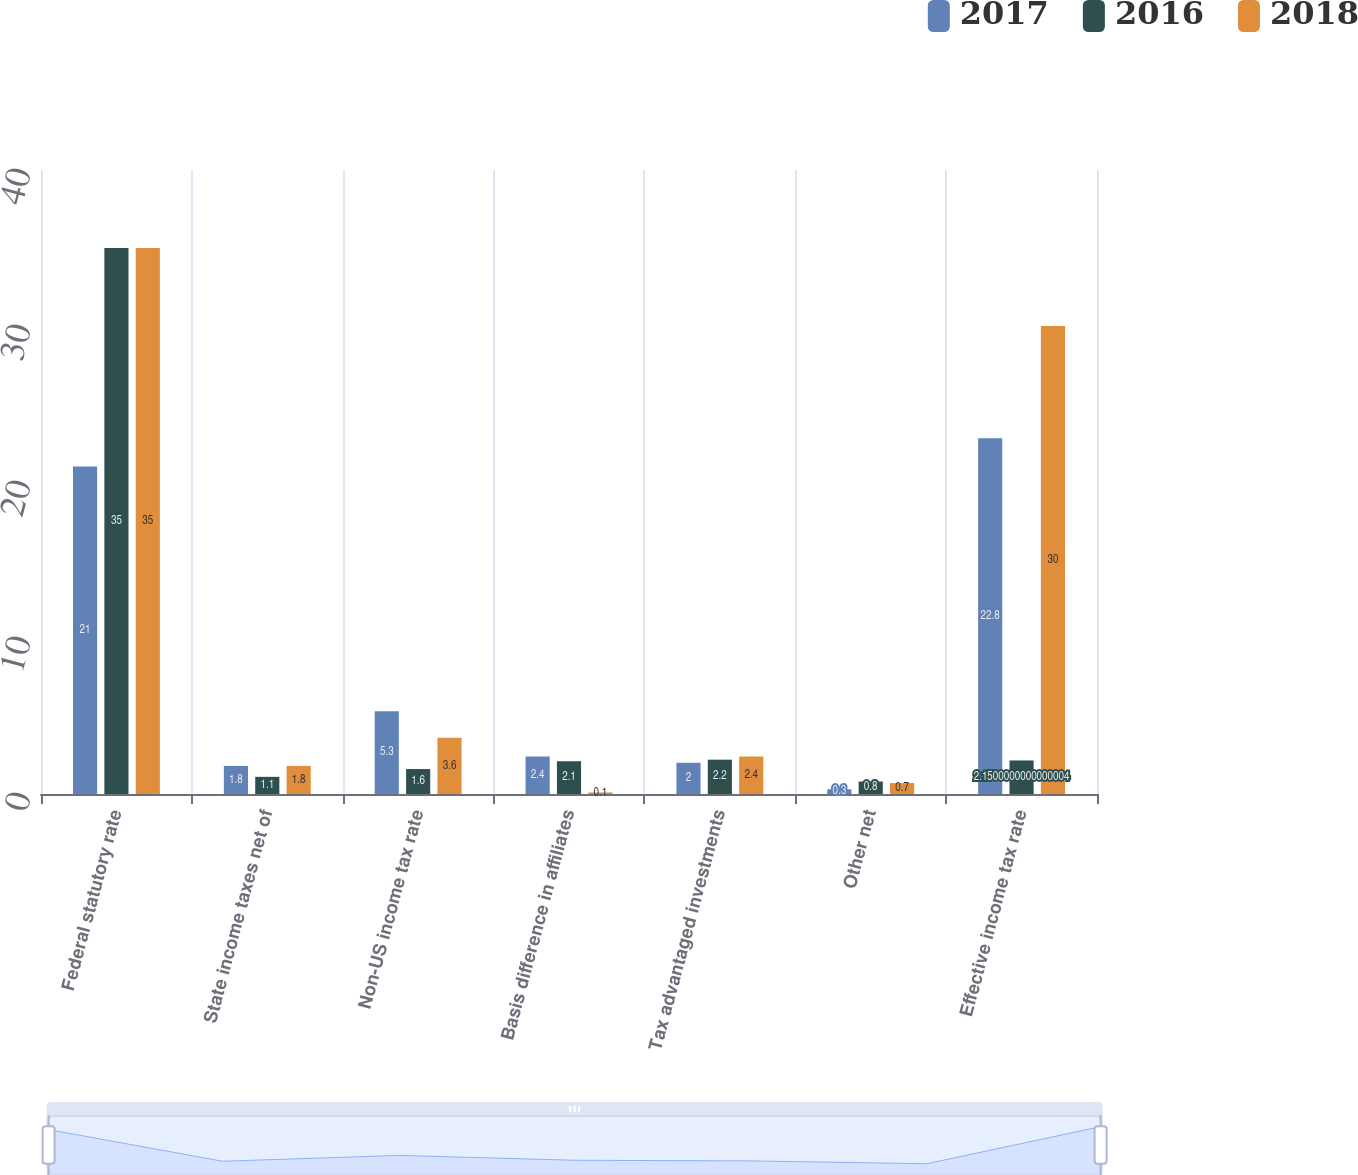<chart> <loc_0><loc_0><loc_500><loc_500><stacked_bar_chart><ecel><fcel>Federal statutory rate<fcel>State income taxes net of<fcel>Non-US income tax rate<fcel>Basis difference in affiliates<fcel>Tax advantaged investments<fcel>Other net<fcel>Effective income tax rate<nl><fcel>2017<fcel>21<fcel>1.8<fcel>5.3<fcel>2.4<fcel>2<fcel>0.3<fcel>22.8<nl><fcel>2016<fcel>35<fcel>1.1<fcel>1.6<fcel>2.1<fcel>2.2<fcel>0.8<fcel>2.15<nl><fcel>2018<fcel>35<fcel>1.8<fcel>3.6<fcel>0.1<fcel>2.4<fcel>0.7<fcel>30<nl></chart> 